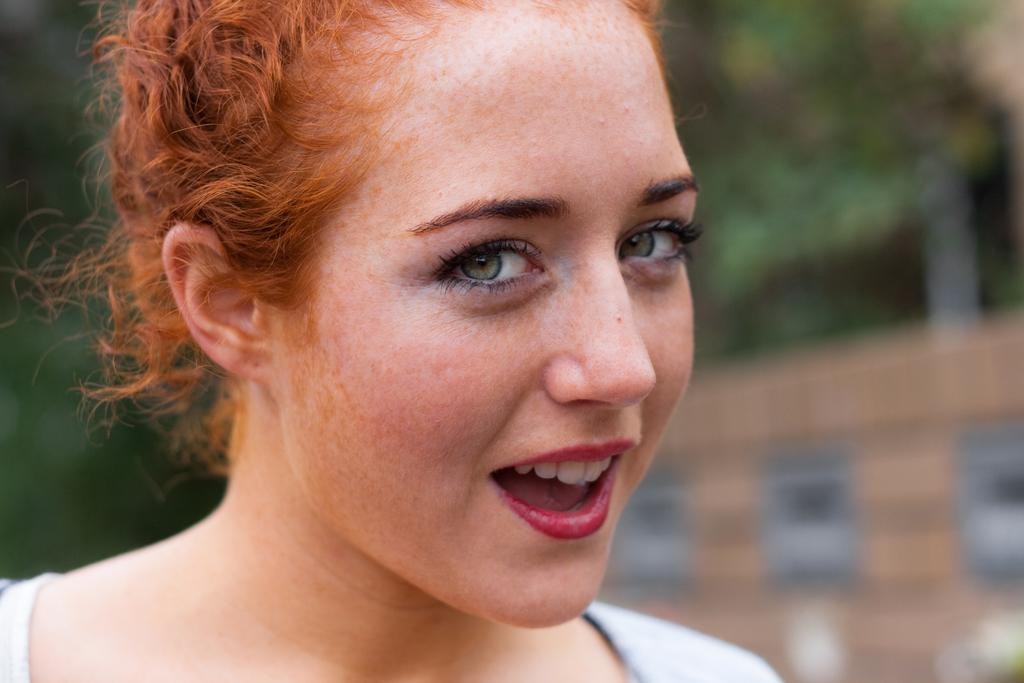Who is present in the image? There is a woman in the image. What is the woman's facial expression? The woman is smiling. Can you describe the background of the image? The background of the image is blurry. What type of twig can be seen in the woman holding in the image? There is no twig present in the image; the woman is not holding anything. 